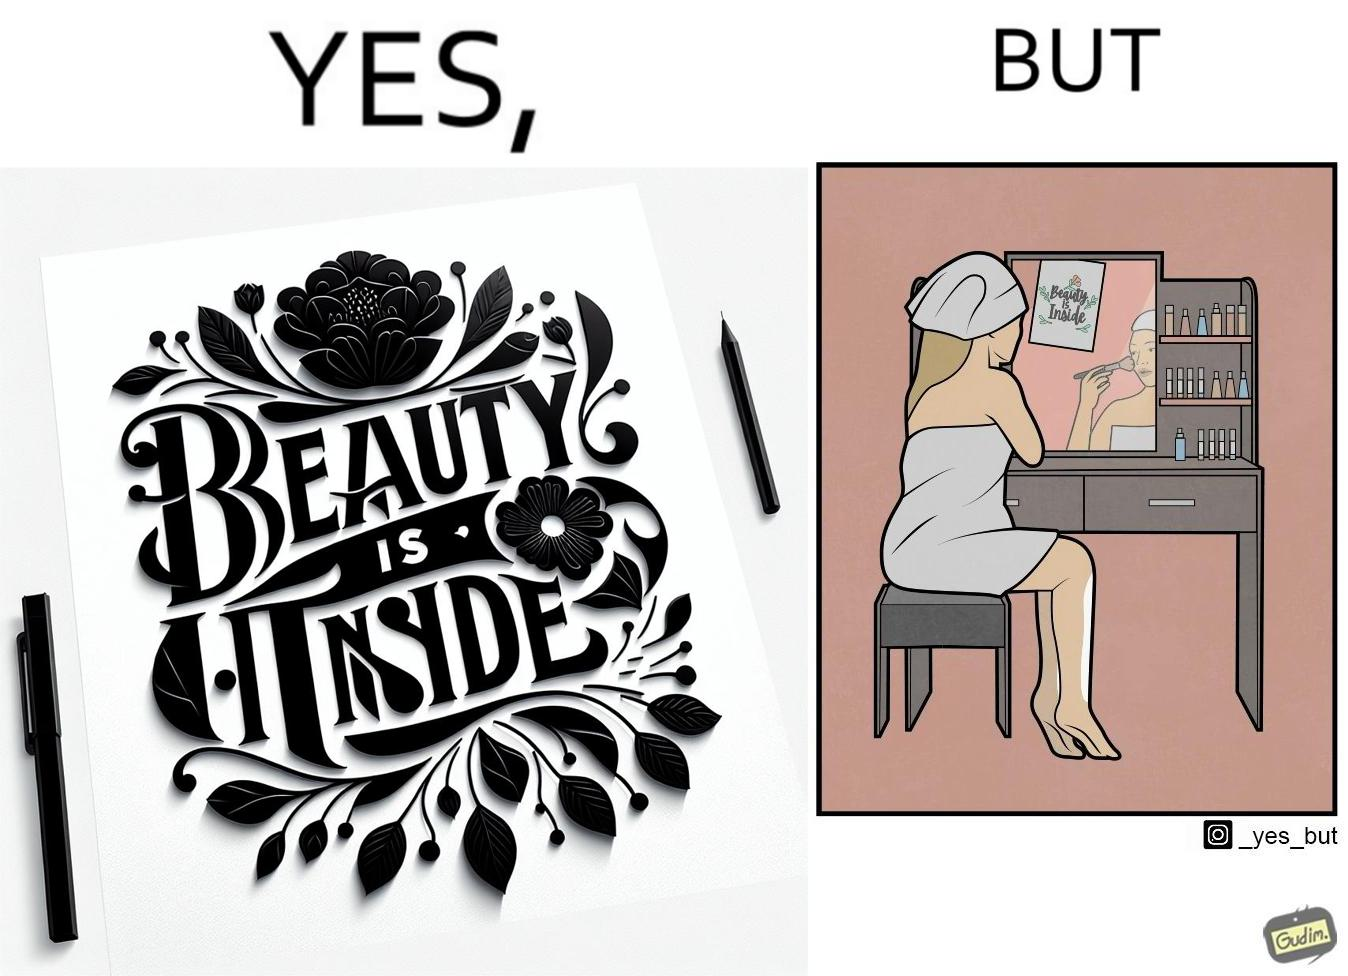Is this image satirical or non-satirical? Yes, this image is satirical. 